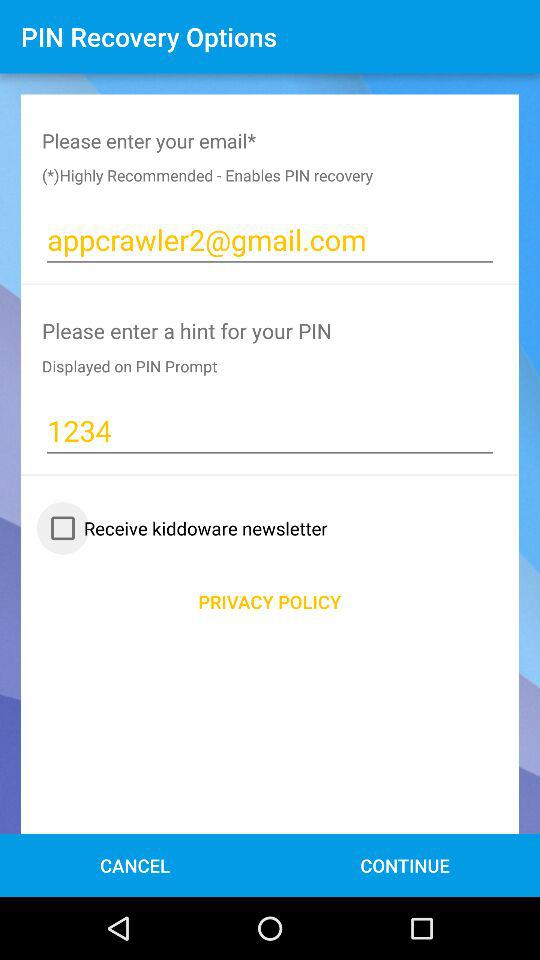What is the PIN? The PIN is 1234. 